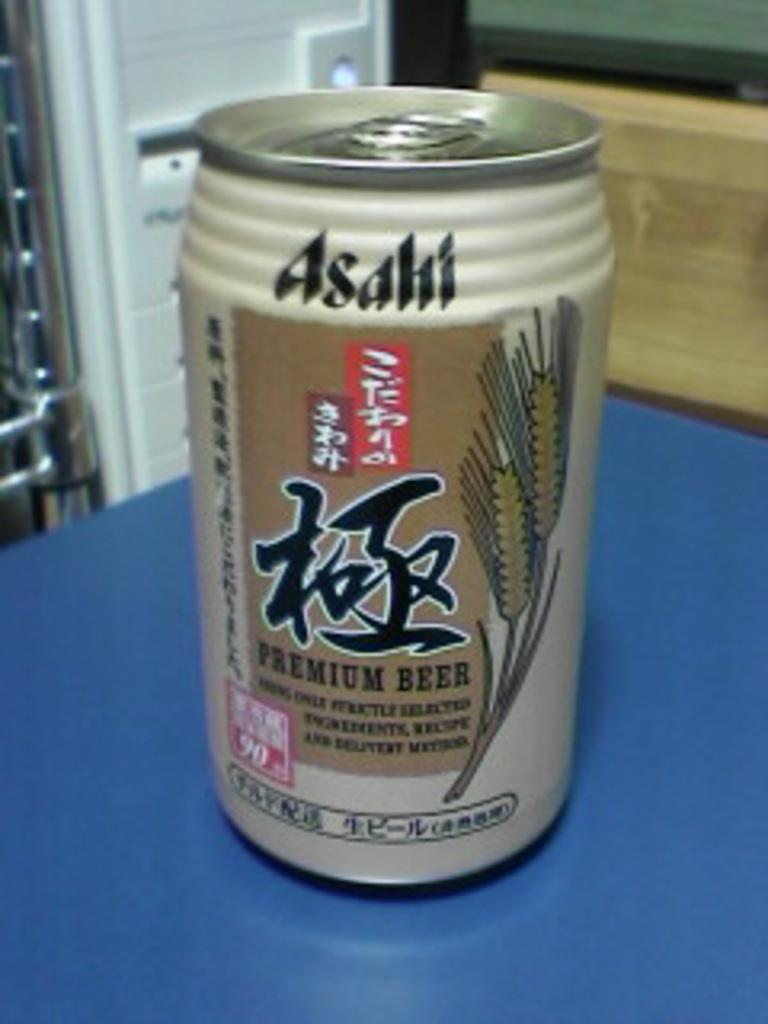<image>
Give a short and clear explanation of the subsequent image. A can of Asian Premium Beer called Asahi. 